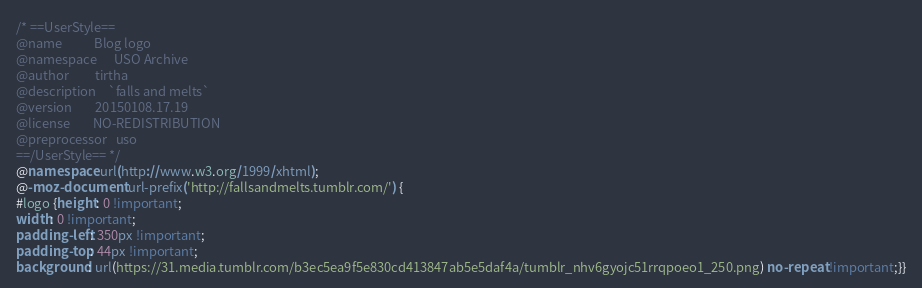<code> <loc_0><loc_0><loc_500><loc_500><_CSS_>/* ==UserStyle==
@name           Blog logo
@namespace      USO Archive
@author         tirtha
@description    `falls and melts`
@version        20150108.17.19
@license        NO-REDISTRIBUTION
@preprocessor   uso
==/UserStyle== */
@namespace url(http://www.w3.org/1999/xhtml); 
@-moz-document url-prefix('http://fallsandmelts.tumblr.com/') { 
#logo {height: 0 !important; 
width: 0 !important; 
padding-left: 350px !important; 
padding-top: 44px !important; 
background: url(https://31.media.tumblr.com/b3ec5ea9f5e830cd413847ab5e5daf4a/tumblr_nhv6gyojc51rrqpoeo1_250.png) no-repeat !important;}}</code> 